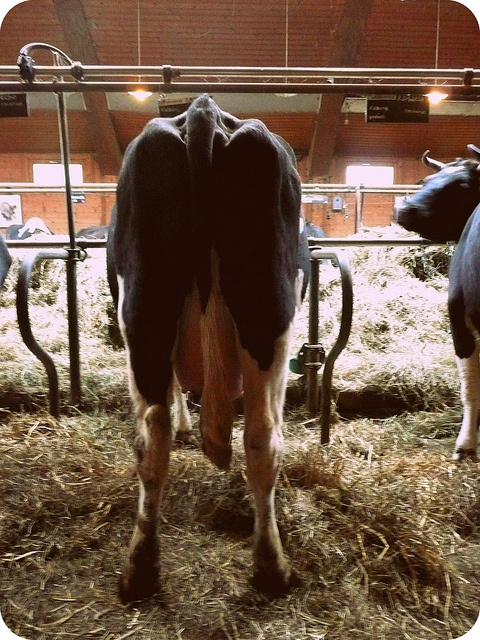Describe the objects in this image and their specific colors. I can see cow in white, black, maroon, and gray tones, cow in white, black, gray, maroon, and lavender tones, cow in white, lavender, darkgray, and gray tones, and cow in white, darkgray, and gray tones in this image. 